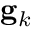<formula> <loc_0><loc_0><loc_500><loc_500>g _ { k }</formula> 